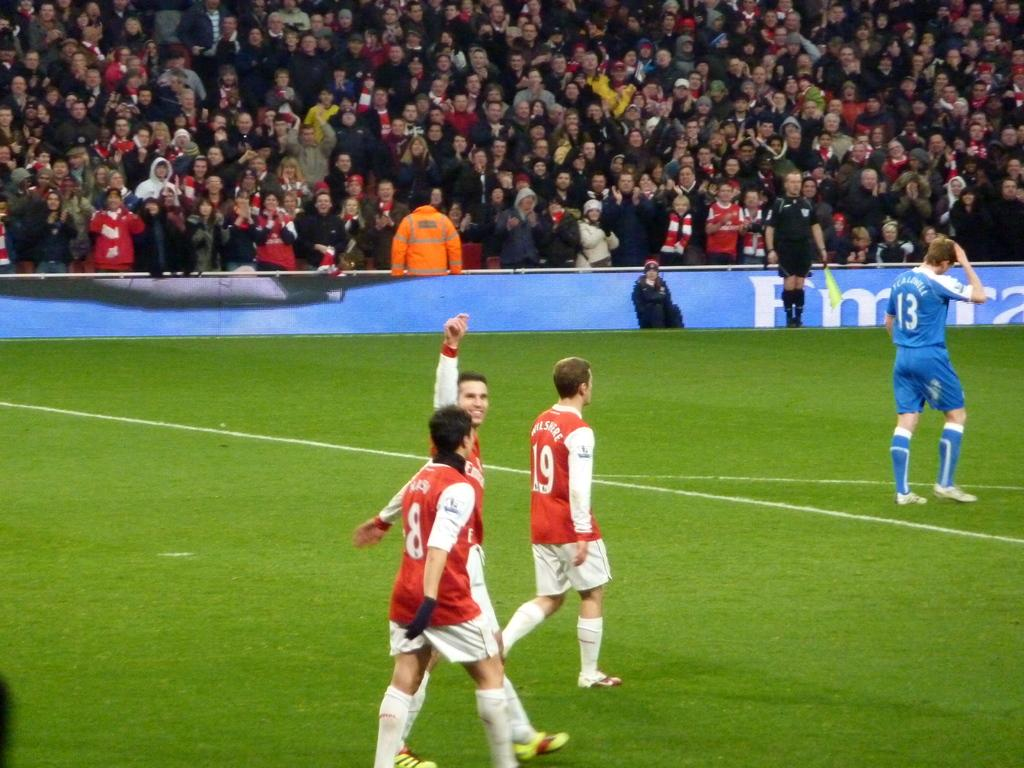Provide a one-sentence caption for the provided image. A player in a blue uniform with number 13 on the back has his hand on his head. 